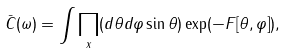<formula> <loc_0><loc_0><loc_500><loc_500>\bar { C } ( \omega ) = \int \prod _ { x } ( d \theta d \varphi \sin \theta ) \exp ( - F [ \theta , \varphi ] ) ,</formula> 